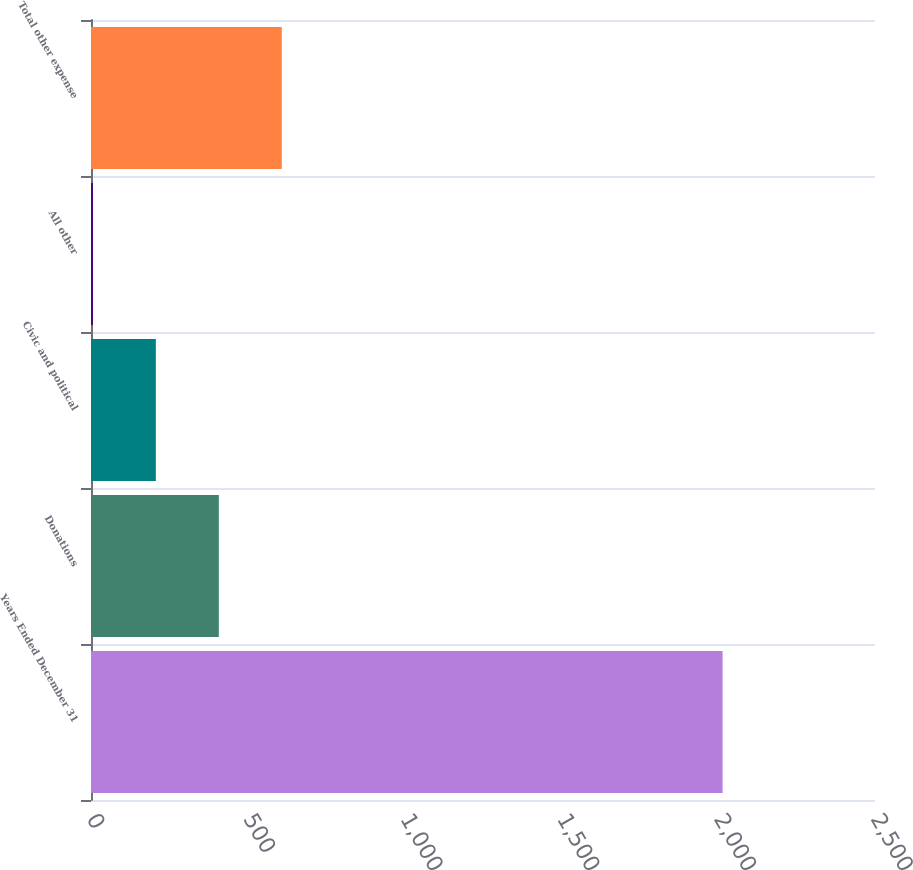Convert chart to OTSL. <chart><loc_0><loc_0><loc_500><loc_500><bar_chart><fcel>Years Ended December 31<fcel>Donations<fcel>Civic and political<fcel>All other<fcel>Total other expense<nl><fcel>2014<fcel>407.6<fcel>206.8<fcel>6<fcel>608.4<nl></chart> 